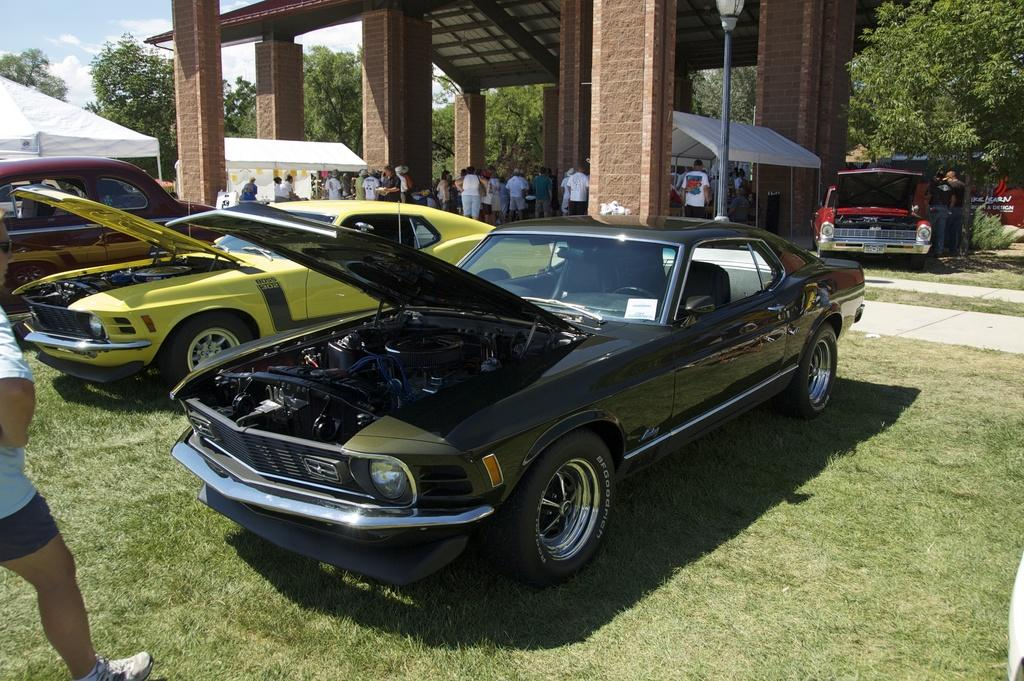How many people are present in the image? There are many people in the image. What are the people wearing? The people are wearing clothes. What type of vehicles can be seen in the image? There are many vehicles in the image. Are the headlights of the vehicles visible? Yes, the headlights of the vehicles are visible. What type of natural environment is present in the image? There is grass in the image. Can you describe any man-made structures in the image? There is a pole and pillars in the image. What else can be seen in the background of the image? There are trees and the sky is visible in the image. How many dolls are present in the image? There are no dolls present in the image. Can you describe the wound be seen on any of the people in the image? There is no indication of any wounds on the people in the image. 